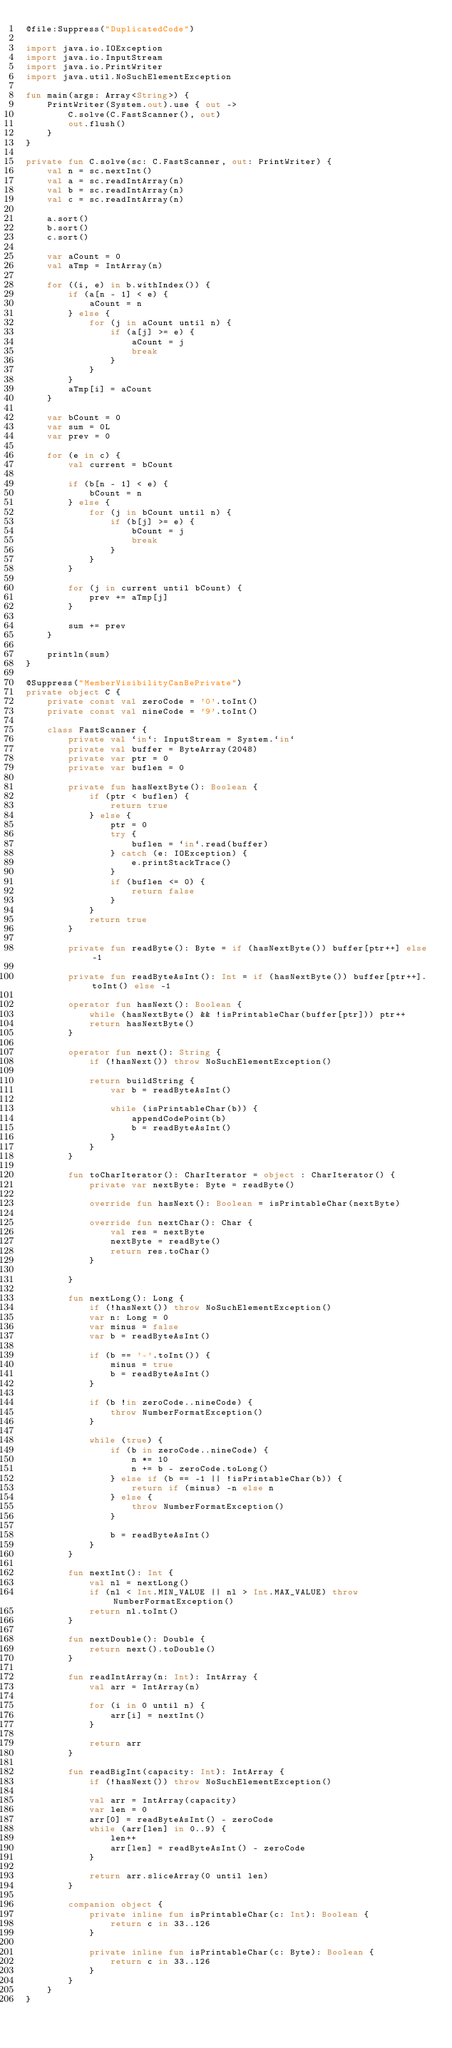<code> <loc_0><loc_0><loc_500><loc_500><_Kotlin_>@file:Suppress("DuplicatedCode")

import java.io.IOException
import java.io.InputStream
import java.io.PrintWriter
import java.util.NoSuchElementException

fun main(args: Array<String>) {
    PrintWriter(System.out).use { out ->
        C.solve(C.FastScanner(), out)
        out.flush()
    }
}

private fun C.solve(sc: C.FastScanner, out: PrintWriter) {
    val n = sc.nextInt()
    val a = sc.readIntArray(n)
    val b = sc.readIntArray(n)
    val c = sc.readIntArray(n)

    a.sort()
    b.sort()
    c.sort()

    var aCount = 0
    val aTmp = IntArray(n)

    for ((i, e) in b.withIndex()) {
        if (a[n - 1] < e) {
            aCount = n
        } else {
            for (j in aCount until n) {
                if (a[j] >= e) {
                    aCount = j
                    break
                }
            }
        }
        aTmp[i] = aCount
    }

    var bCount = 0
    var sum = 0L
    var prev = 0

    for (e in c) {
        val current = bCount

        if (b[n - 1] < e) {
            bCount = n
        } else {
            for (j in bCount until n) {
                if (b[j] >= e) {
                    bCount = j
                    break
                }
            }
        }

        for (j in current until bCount) {
            prev += aTmp[j]
        }

        sum += prev
    }

    println(sum)
}

@Suppress("MemberVisibilityCanBePrivate")
private object C {
    private const val zeroCode = '0'.toInt()
    private const val nineCode = '9'.toInt()

    class FastScanner {
        private val `in`: InputStream = System.`in`
        private val buffer = ByteArray(2048)
        private var ptr = 0
        private var buflen = 0

        private fun hasNextByte(): Boolean {
            if (ptr < buflen) {
                return true
            } else {
                ptr = 0
                try {
                    buflen = `in`.read(buffer)
                } catch (e: IOException) {
                    e.printStackTrace()
                }
                if (buflen <= 0) {
                    return false
                }
            }
            return true
        }

        private fun readByte(): Byte = if (hasNextByte()) buffer[ptr++] else -1

        private fun readByteAsInt(): Int = if (hasNextByte()) buffer[ptr++].toInt() else -1

        operator fun hasNext(): Boolean {
            while (hasNextByte() && !isPrintableChar(buffer[ptr])) ptr++
            return hasNextByte()
        }

        operator fun next(): String {
            if (!hasNext()) throw NoSuchElementException()

            return buildString {
                var b = readByteAsInt()

                while (isPrintableChar(b)) {
                    appendCodePoint(b)
                    b = readByteAsInt()
                }
            }
        }

        fun toCharIterator(): CharIterator = object : CharIterator() {
            private var nextByte: Byte = readByte()

            override fun hasNext(): Boolean = isPrintableChar(nextByte)

            override fun nextChar(): Char {
                val res = nextByte
                nextByte = readByte()
                return res.toChar()
            }

        }

        fun nextLong(): Long {
            if (!hasNext()) throw NoSuchElementException()
            var n: Long = 0
            var minus = false
            var b = readByteAsInt()

            if (b == '-'.toInt()) {
                minus = true
                b = readByteAsInt()
            }

            if (b !in zeroCode..nineCode) {
                throw NumberFormatException()
            }

            while (true) {
                if (b in zeroCode..nineCode) {
                    n *= 10
                    n += b - zeroCode.toLong()
                } else if (b == -1 || !isPrintableChar(b)) {
                    return if (minus) -n else n
                } else {
                    throw NumberFormatException()
                }

                b = readByteAsInt()
            }
        }

        fun nextInt(): Int {
            val nl = nextLong()
            if (nl < Int.MIN_VALUE || nl > Int.MAX_VALUE) throw NumberFormatException()
            return nl.toInt()
        }

        fun nextDouble(): Double {
            return next().toDouble()
        }

        fun readIntArray(n: Int): IntArray {
            val arr = IntArray(n)

            for (i in 0 until n) {
                arr[i] = nextInt()
            }

            return arr
        }

        fun readBigInt(capacity: Int): IntArray {
            if (!hasNext()) throw NoSuchElementException()

            val arr = IntArray(capacity)
            var len = 0
            arr[0] = readByteAsInt() - zeroCode
            while (arr[len] in 0..9) {
                len++
                arr[len] = readByteAsInt() - zeroCode
            }

            return arr.sliceArray(0 until len)
        }

        companion object {
            private inline fun isPrintableChar(c: Int): Boolean {
                return c in 33..126
            }

            private inline fun isPrintableChar(c: Byte): Boolean {
                return c in 33..126
            }
        }
    }
}
</code> 